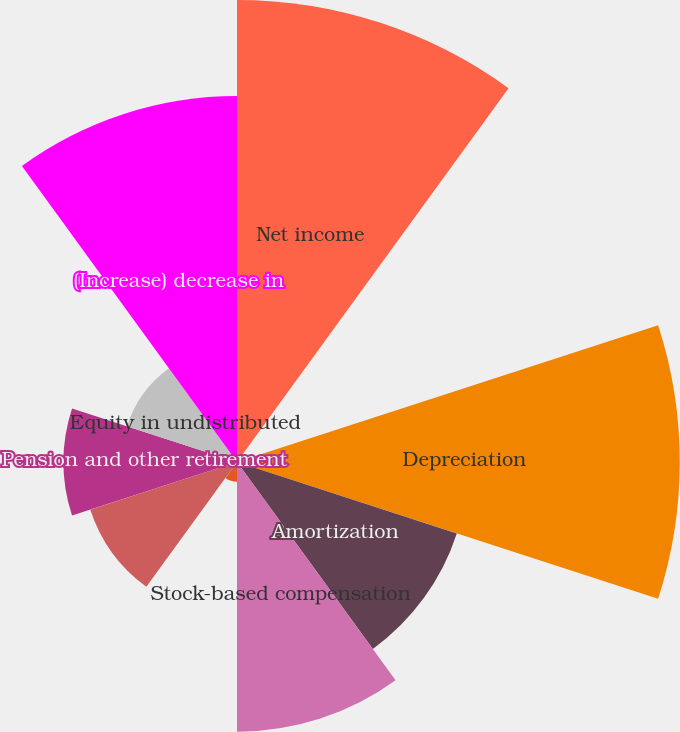<chart> <loc_0><loc_0><loc_500><loc_500><pie_chart><fcel>Net income<fcel>Loss (gain) from discontinued<fcel>Depreciation<fcel>Amortization<fcel>Stock-based compensation<fcel>Loss on sales of equipment and<fcel>Deferred income taxes<fcel>Pension and other retirement<fcel>Equity in undistributed<fcel>(Increase) decrease in<nl><fcel>20.67%<fcel>0.02%<fcel>19.81%<fcel>10.34%<fcel>12.07%<fcel>0.88%<fcel>6.9%<fcel>7.76%<fcel>5.18%<fcel>16.37%<nl></chart> 